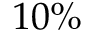<formula> <loc_0><loc_0><loc_500><loc_500>1 0 \%</formula> 